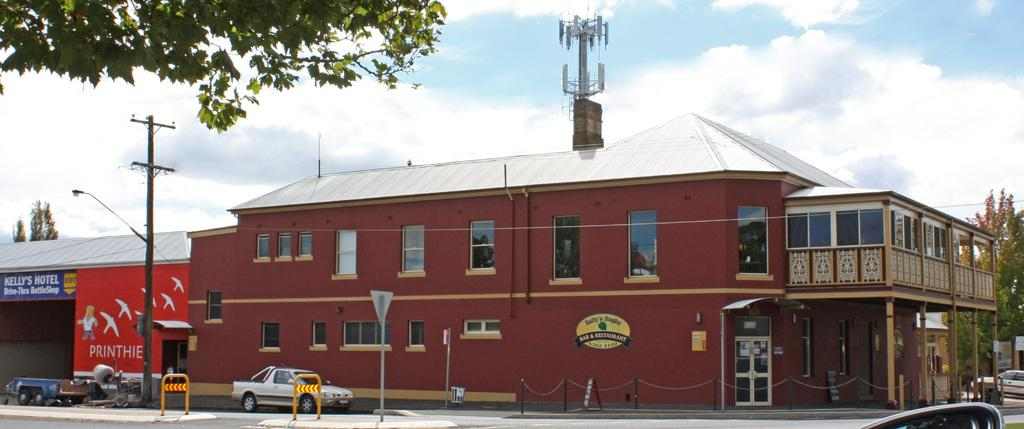What can be seen on the road in the image? There are vehicles on the road in the image. What might be used to control traffic or block access in the image? Barricades are present in the image. What type of vertical structures can be seen in the image? Poles are visible in the image. What type of signage or advertisements might be present in the image? Boards are present in the image. What type of man-made structures can be seen in the image? Buildings are visible in the image. What type of small storage structure can be seen in the image? There is a shed in the image. What type of natural vegetation can be seen in the image? Trees are present in the image. What type of illumination can be seen in the image? Light is visible in the image. What type of tall structure can be seen in the image? There is a tower in the image. What can be seen in the background of the image? The sky is visible in the background of the image. What type of atmospheric phenomena can be seen in the sky? Clouds are present in the sky. How does the pump affect the decision-making process in the image? There is no pump present in the image, so it cannot affect any decision-making process. What type of mental activity can be seen in the image? There is no indication of any mental activity in the image; it primarily features man-made and natural structures. 